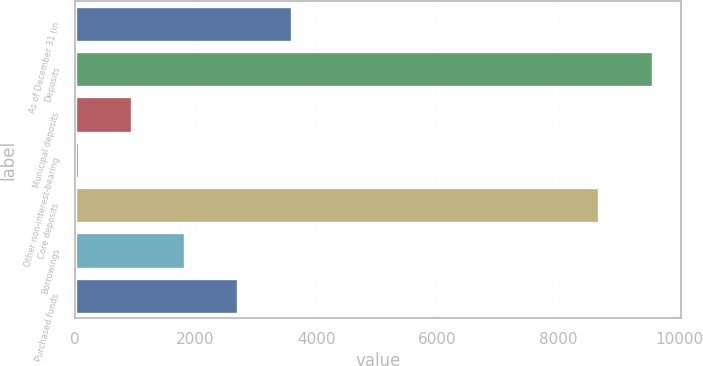Convert chart to OTSL. <chart><loc_0><loc_0><loc_500><loc_500><bar_chart><fcel>As of December 31 (in<fcel>Deposits<fcel>Municipal deposits<fcel>Other non-interest-bearing<fcel>Core deposits<fcel>Borrowings<fcel>Purchased funds<nl><fcel>3589.8<fcel>9559.7<fcel>953.7<fcel>75<fcel>8681<fcel>1832.4<fcel>2711.1<nl></chart> 